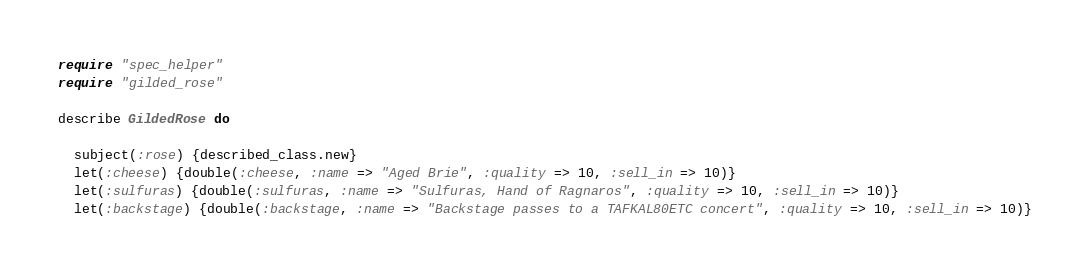Convert code to text. <code><loc_0><loc_0><loc_500><loc_500><_Ruby_>require "spec_helper"
require "gilded_rose"

describe GildedRose do

  subject(:rose) {described_class.new}
  let(:cheese) {double(:cheese, :name => "Aged Brie", :quality => 10, :sell_in => 10)}
  let(:sulfuras) {double(:sulfuras, :name => "Sulfuras, Hand of Ragnaros", :quality => 10, :sell_in => 10)}
  let(:backstage) {double(:backstage, :name => "Backstage passes to a TAFKAL80ETC concert", :quality => 10, :sell_in => 10)}
</code> 